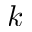Convert formula to latex. <formula><loc_0><loc_0><loc_500><loc_500>k</formula> 